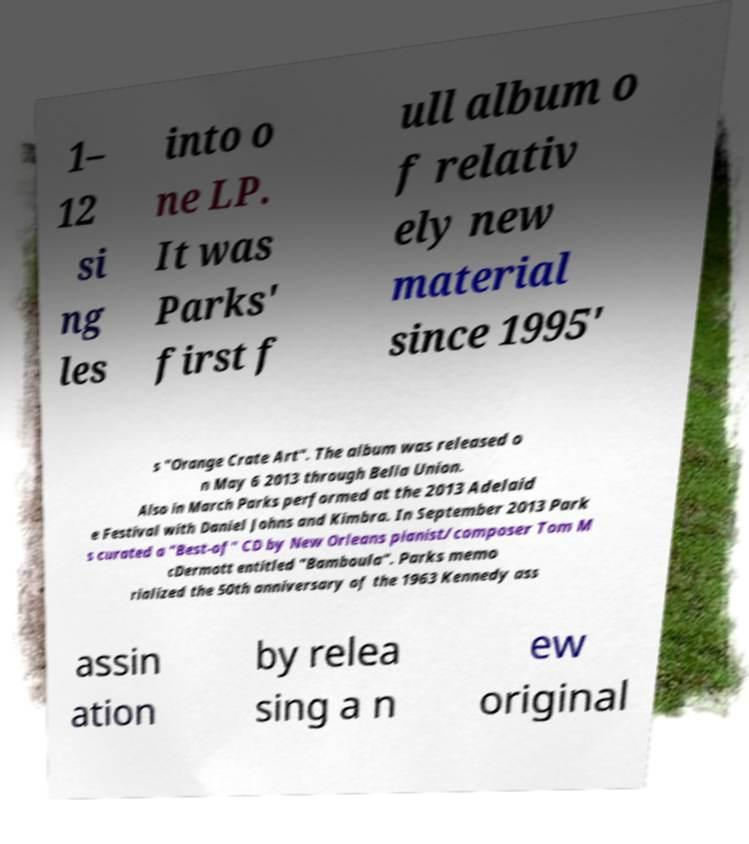Please identify and transcribe the text found in this image. 1– 12 si ng les into o ne LP. It was Parks' first f ull album o f relativ ely new material since 1995' s "Orange Crate Art". The album was released o n May 6 2013 through Bella Union. Also in March Parks performed at the 2013 Adelaid e Festival with Daniel Johns and Kimbra. In September 2013 Park s curated a "Best-of" CD by New Orleans pianist/composer Tom M cDermott entitled "Bamboula". Parks memo rialized the 50th anniversary of the 1963 Kennedy ass assin ation by relea sing a n ew original 